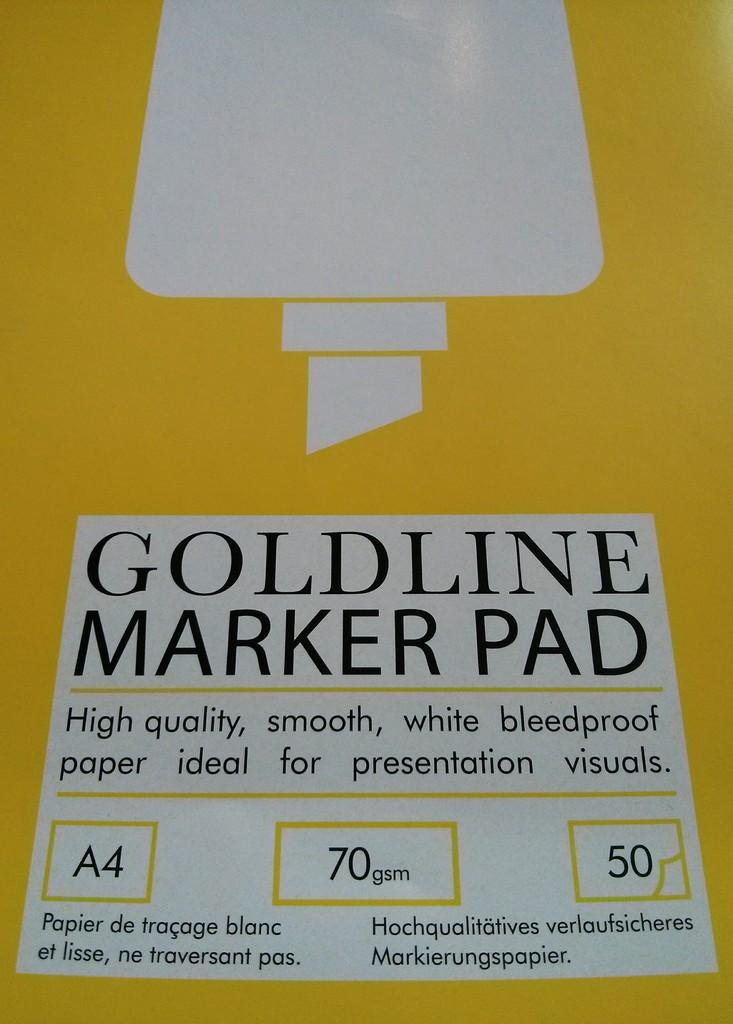<image>
Summarize the visual content of the image. A yellow cover for a Goldline marker pad. 